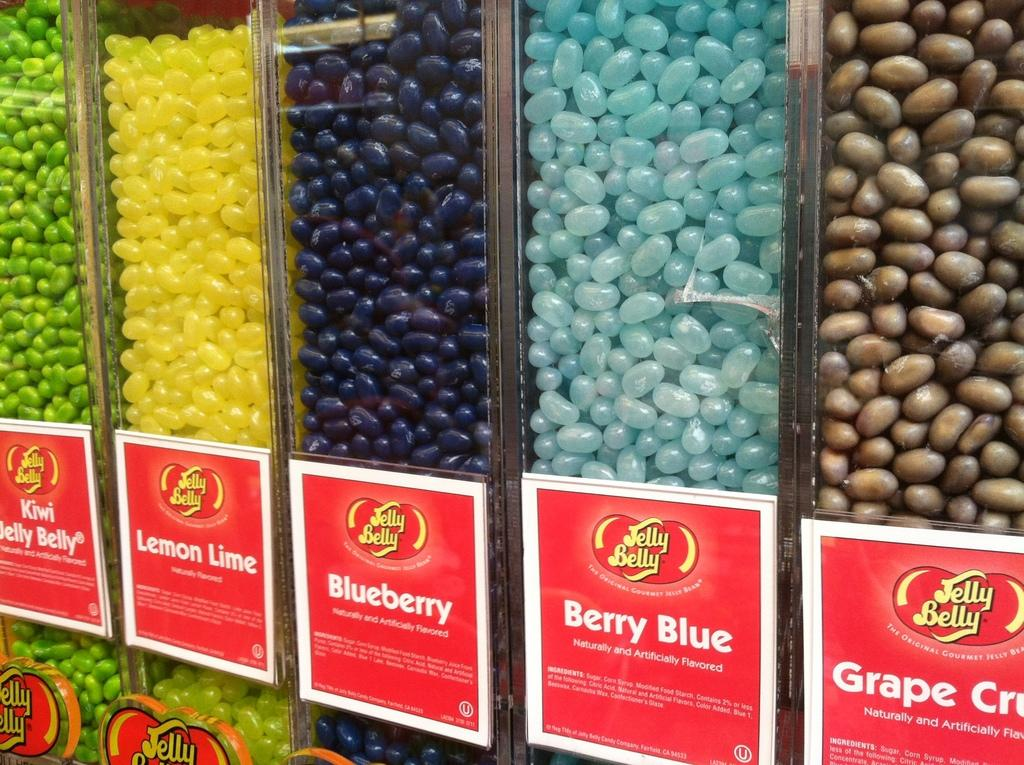What is inside the jars in the image? There are food items in the jars. What covers the jars in the image? There are boards on the jars. What can be read on the boards? Text is present on the boards. How does the farmer interact with the jars in the image? There is no farmer present in the image, so it is not possible to determine how they might interact with the jars. 